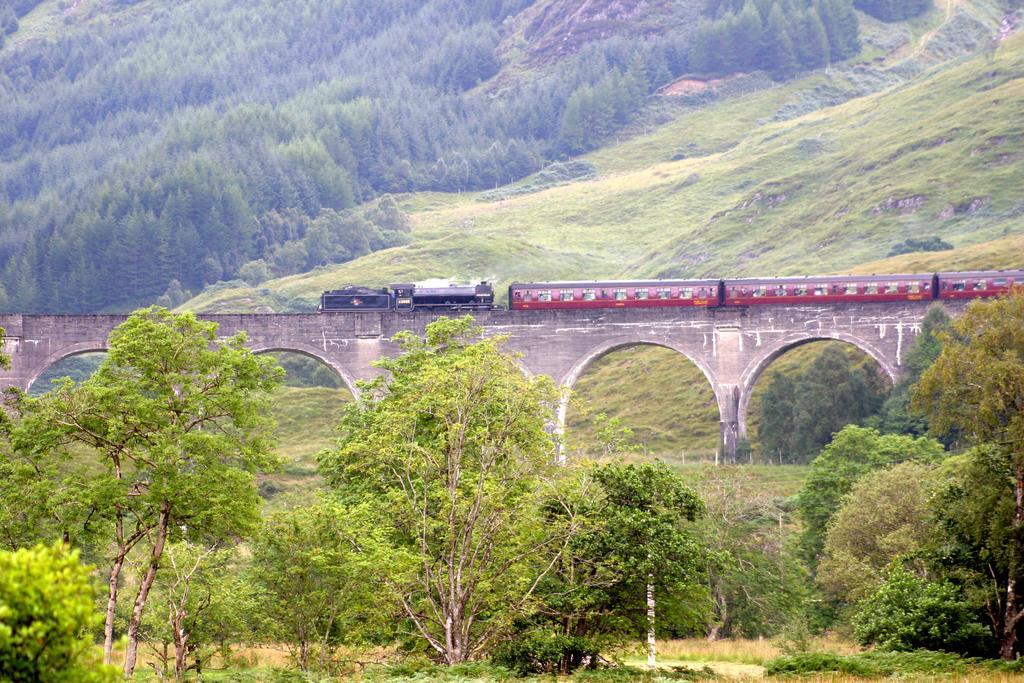Can you describe this image briefly? In this image there is a bridge and we can see a train on the bridge and there are trees. 